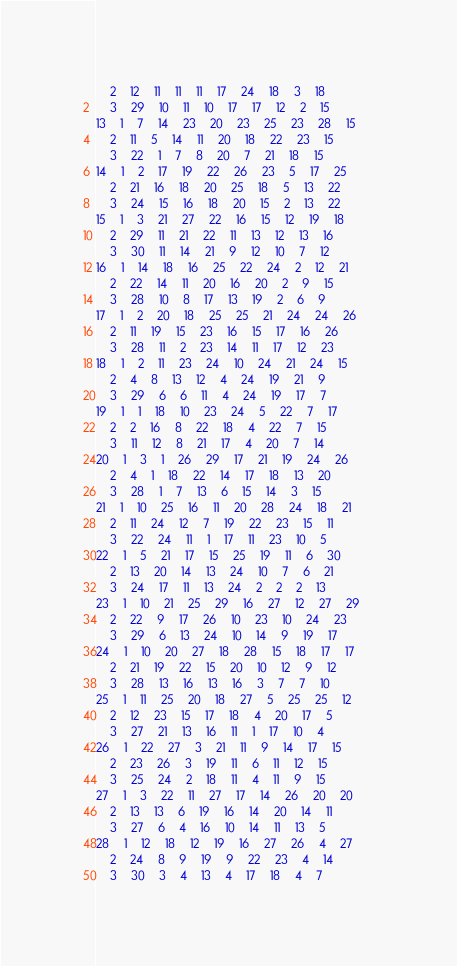Convert code to text. <code><loc_0><loc_0><loc_500><loc_500><_ObjectiveC_>	2	12	11	11	11	17	24	18	3	18	
	3	29	10	11	10	17	17	12	2	15	
13	1	7	14	23	20	23	25	23	28	15	
	2	11	5	14	11	20	18	22	23	15	
	3	22	1	7	8	20	7	21	18	15	
14	1	2	17	19	22	26	23	5	17	25	
	2	21	16	18	20	25	18	5	13	22	
	3	24	15	16	18	20	15	2	13	22	
15	1	3	21	27	22	16	15	12	19	18	
	2	29	11	21	22	11	13	12	13	16	
	3	30	11	14	21	9	12	10	7	12	
16	1	14	18	16	25	22	24	2	12	21	
	2	22	14	11	20	16	20	2	9	15	
	3	28	10	8	17	13	19	2	6	9	
17	1	2	20	18	25	25	21	24	24	26	
	2	11	19	15	23	16	15	17	16	26	
	3	28	11	2	23	14	11	17	12	23	
18	1	2	11	23	24	10	24	21	24	15	
	2	4	8	13	12	4	24	19	21	9	
	3	29	6	6	11	4	24	19	17	7	
19	1	1	18	10	23	24	5	22	7	17	
	2	2	16	8	22	18	4	22	7	15	
	3	11	12	8	21	17	4	20	7	14	
20	1	3	1	26	29	17	21	19	24	26	
	2	4	1	18	22	14	17	18	13	20	
	3	28	1	7	13	6	15	14	3	15	
21	1	10	25	16	11	20	28	24	18	21	
	2	11	24	12	7	19	22	23	15	11	
	3	22	24	11	1	17	11	23	10	5	
22	1	5	21	17	15	25	19	11	6	30	
	2	13	20	14	13	24	10	7	6	21	
	3	24	17	11	13	24	2	2	2	13	
23	1	10	21	25	29	16	27	12	27	29	
	2	22	9	17	26	10	23	10	24	23	
	3	29	6	13	24	10	14	9	19	17	
24	1	10	20	27	18	28	15	18	17	17	
	2	21	19	22	15	20	10	12	9	12	
	3	28	13	16	13	16	3	7	7	10	
25	1	11	25	20	18	27	5	25	25	12	
	2	12	23	15	17	18	4	20	17	5	
	3	27	21	13	16	11	1	17	10	4	
26	1	22	27	3	21	11	9	14	17	15	
	2	23	26	3	19	11	6	11	12	15	
	3	25	24	2	18	11	4	11	9	15	
27	1	3	22	11	27	17	14	26	20	20	
	2	13	13	6	19	16	14	20	14	11	
	3	27	6	4	16	10	14	11	13	5	
28	1	12	18	12	19	16	27	26	4	27	
	2	24	8	9	19	9	22	23	4	14	
	3	30	3	4	13	4	17	18	4	7	</code> 